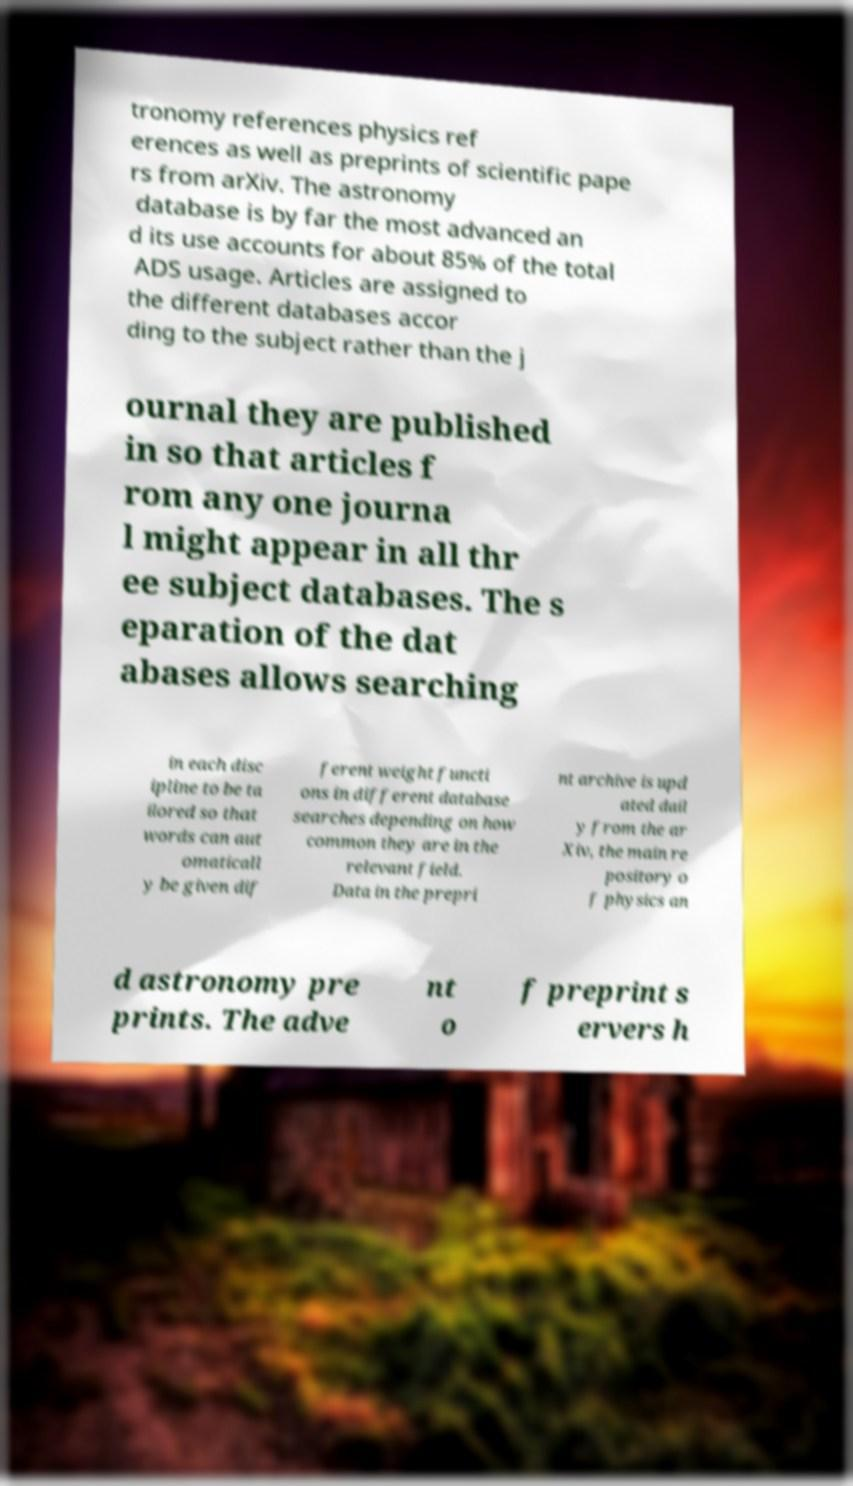Can you accurately transcribe the text from the provided image for me? tronomy references physics ref erences as well as preprints of scientific pape rs from arXiv. The astronomy database is by far the most advanced an d its use accounts for about 85% of the total ADS usage. Articles are assigned to the different databases accor ding to the subject rather than the j ournal they are published in so that articles f rom any one journa l might appear in all thr ee subject databases. The s eparation of the dat abases allows searching in each disc ipline to be ta ilored so that words can aut omaticall y be given dif ferent weight functi ons in different database searches depending on how common they are in the relevant field. Data in the prepri nt archive is upd ated dail y from the ar Xiv, the main re pository o f physics an d astronomy pre prints. The adve nt o f preprint s ervers h 